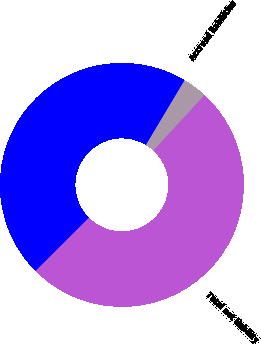Convert chart. <chart><loc_0><loc_0><loc_500><loc_500><pie_chart><fcel>Accrued liabilities<fcel>Deferred income taxes and<fcel>Total net liability<nl><fcel>3.27%<fcel>46.06%<fcel>50.67%<nl></chart> 